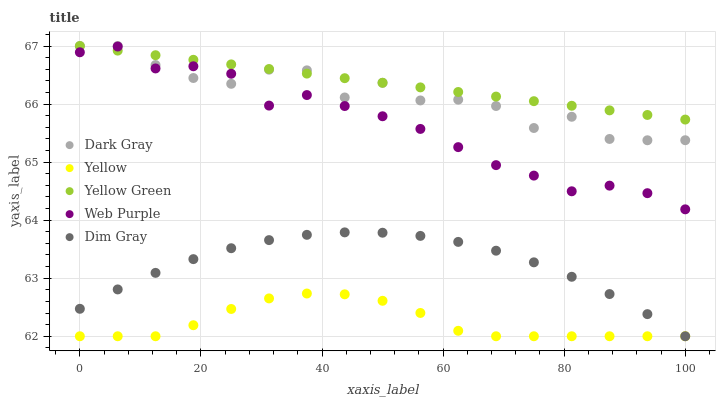Does Yellow have the minimum area under the curve?
Answer yes or no. Yes. Does Yellow Green have the maximum area under the curve?
Answer yes or no. Yes. Does Web Purple have the minimum area under the curve?
Answer yes or no. No. Does Web Purple have the maximum area under the curve?
Answer yes or no. No. Is Yellow Green the smoothest?
Answer yes or no. Yes. Is Dark Gray the roughest?
Answer yes or no. Yes. Is Web Purple the smoothest?
Answer yes or no. No. Is Web Purple the roughest?
Answer yes or no. No. Does Dim Gray have the lowest value?
Answer yes or no. Yes. Does Web Purple have the lowest value?
Answer yes or no. No. Does Yellow Green have the highest value?
Answer yes or no. Yes. Does Web Purple have the highest value?
Answer yes or no. No. Is Dim Gray less than Web Purple?
Answer yes or no. Yes. Is Dark Gray greater than Dim Gray?
Answer yes or no. Yes. Does Yellow Green intersect Dark Gray?
Answer yes or no. Yes. Is Yellow Green less than Dark Gray?
Answer yes or no. No. Is Yellow Green greater than Dark Gray?
Answer yes or no. No. Does Dim Gray intersect Web Purple?
Answer yes or no. No. 